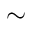<formula> <loc_0><loc_0><loc_500><loc_500>\sim</formula> 